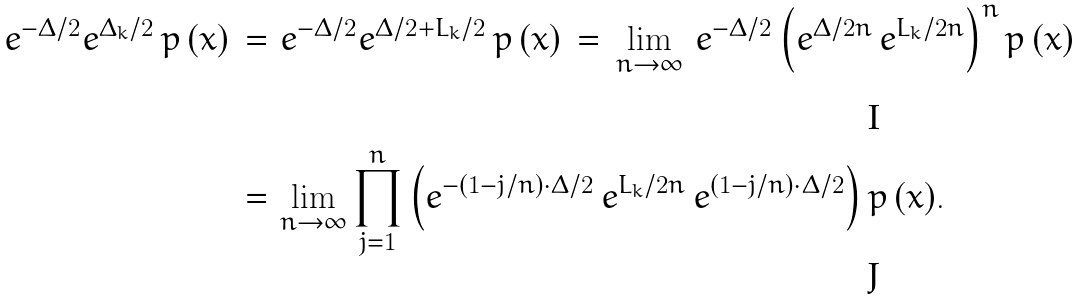<formula> <loc_0><loc_0><loc_500><loc_500>e ^ { - \Delta / 2 } e ^ { \Delta _ { k } / 2 } \, p \, ( x ) \, = \, & \, e ^ { - \Delta / 2 } e ^ { \Delta / 2 + L _ { k } / 2 } \, p \, ( x ) \, = \, \lim _ { n \to \infty } \, e ^ { - \Delta / 2 } \left ( e ^ { \Delta / 2 n } \, e ^ { L _ { k } / 2 n } \right ) ^ { n } p \, ( x ) \, \\ = \, & \lim _ { n \to \infty } \prod _ { j = 1 } ^ { n } \left ( e ^ { - ( 1 - j / n ) \cdot \Delta / 2 } \, e ^ { L _ { k } / 2 n } \, e ^ { ( 1 - j / n ) \cdot \Delta / 2 } \right ) p \, ( x ) .</formula> 